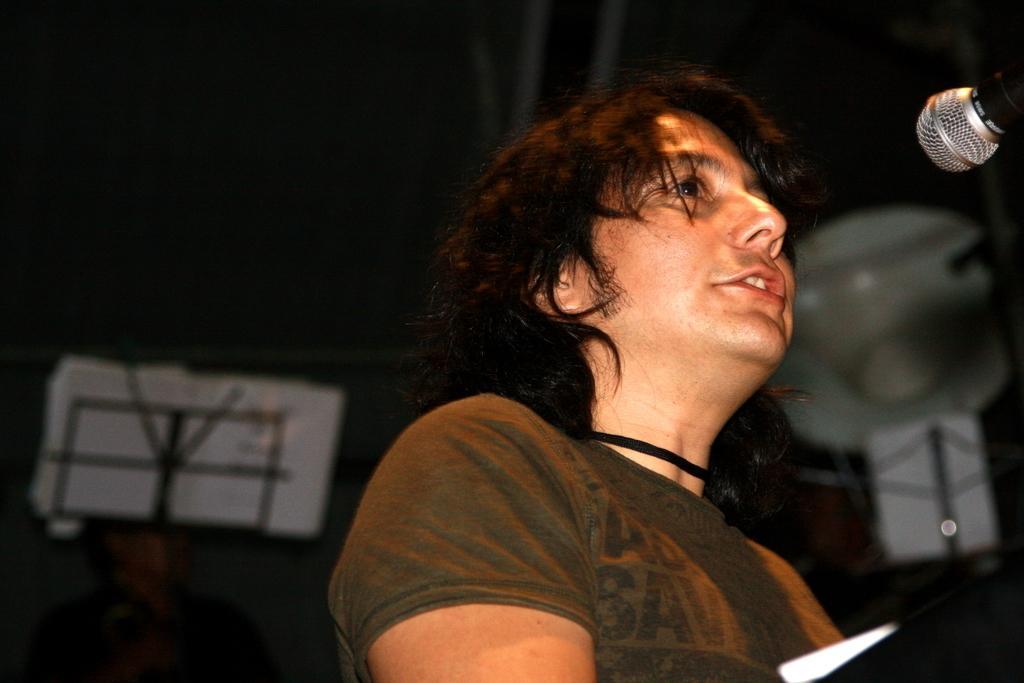How would you summarize this image in a sentence or two? In this picture I can see a man standing and singing with the help of a microphone and I can see a book to the stand and I can see a black color background. 